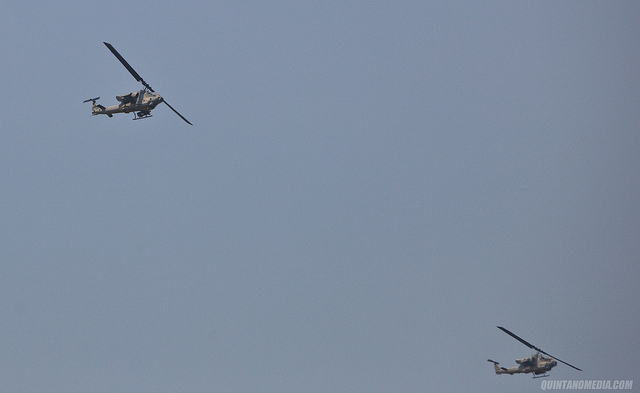Identify the text displayed in this image. QUINTANOMEDIA COM 